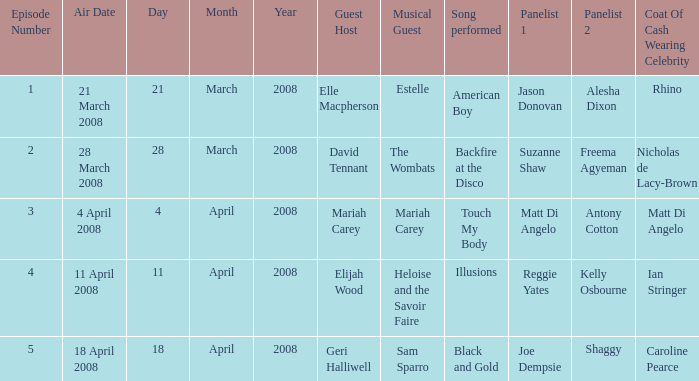Name the total number of episodes for coat of cash wearing celebrity is matt di angelo 1.0. 